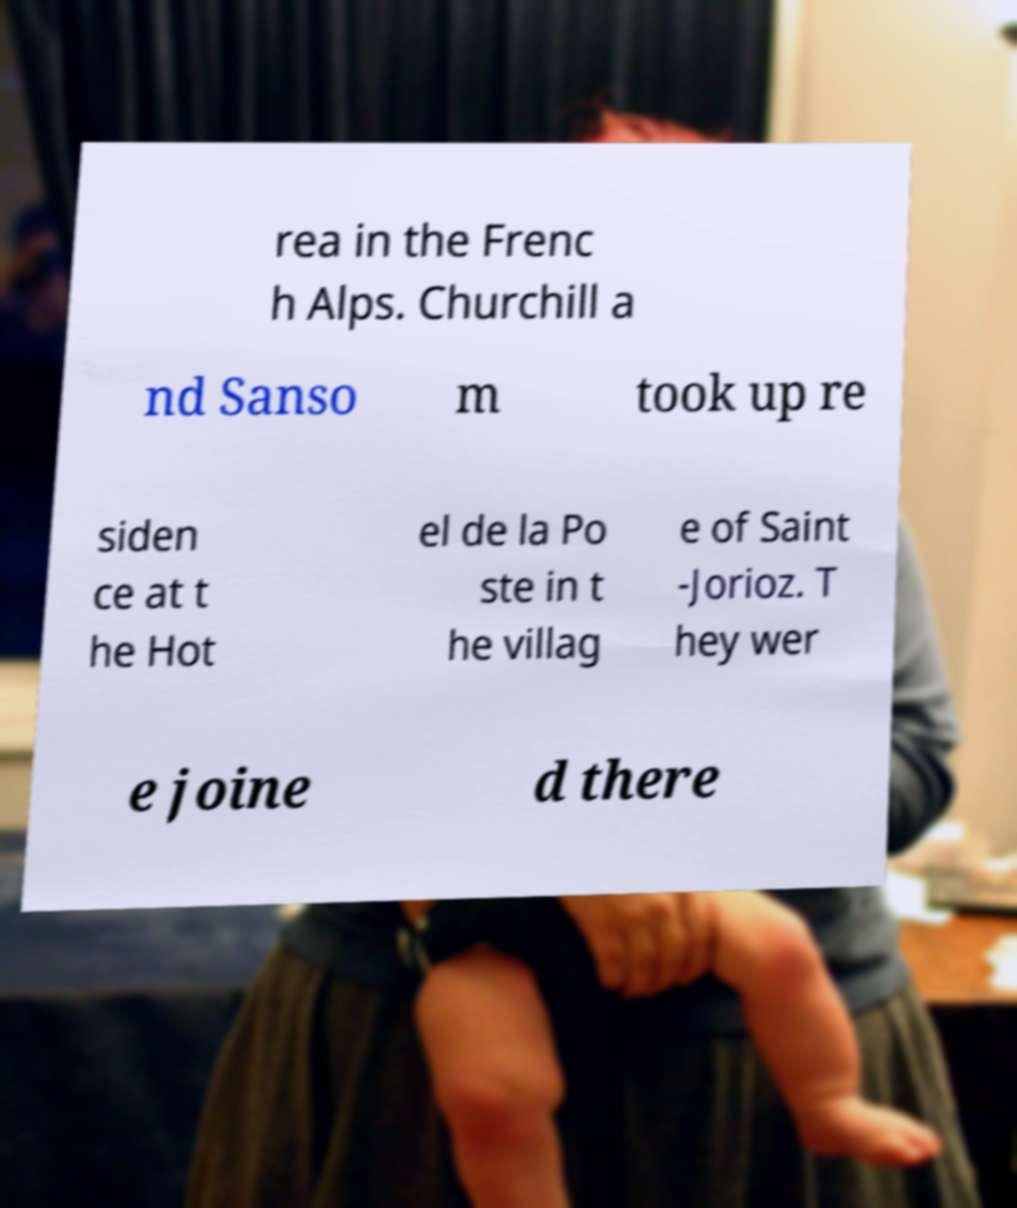Can you accurately transcribe the text from the provided image for me? rea in the Frenc h Alps. Churchill a nd Sanso m took up re siden ce at t he Hot el de la Po ste in t he villag e of Saint -Jorioz. T hey wer e joine d there 